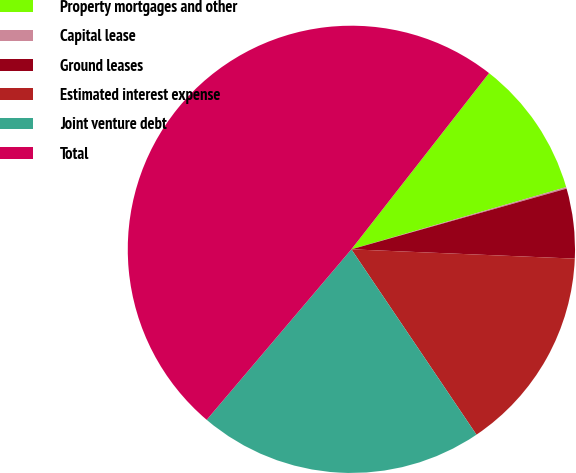Convert chart. <chart><loc_0><loc_0><loc_500><loc_500><pie_chart><fcel>Property mortgages and other<fcel>Capital lease<fcel>Ground leases<fcel>Estimated interest expense<fcel>Joint venture debt<fcel>Total<nl><fcel>9.96%<fcel>0.11%<fcel>5.04%<fcel>14.89%<fcel>20.65%<fcel>49.36%<nl></chart> 